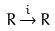<formula> <loc_0><loc_0><loc_500><loc_500>R \, { \stackrel { i } { \to } } \, R</formula> 